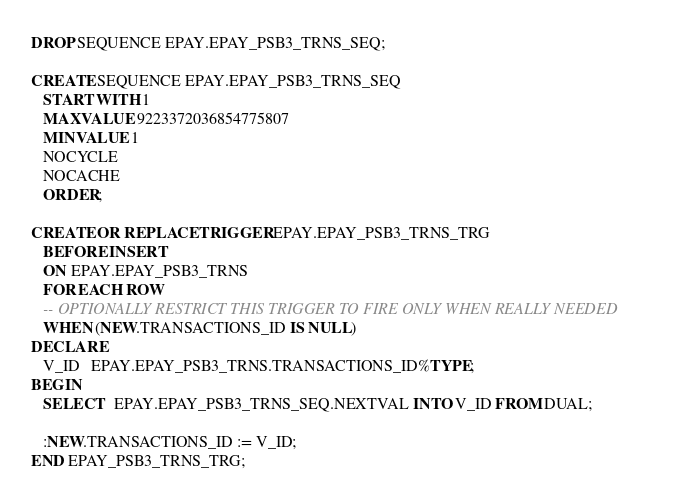<code> <loc_0><loc_0><loc_500><loc_500><_SQL_>DROP SEQUENCE EPAY.EPAY_PSB3_TRNS_SEQ;

CREATE SEQUENCE EPAY.EPAY_PSB3_TRNS_SEQ
   START WITH 1
   MAXVALUE 9223372036854775807
   MINVALUE 1
   NOCYCLE
   NOCACHE
   ORDER;

CREATE OR REPLACE TRIGGER EPAY.EPAY_PSB3_TRNS_TRG
   BEFORE INSERT
   ON EPAY.EPAY_PSB3_TRNS
   FOR EACH ROW
   -- OPTIONALLY RESTRICT THIS TRIGGER TO FIRE ONLY WHEN REALLY NEEDED
   WHEN (NEW.TRANSACTIONS_ID IS NULL)
DECLARE
   V_ID   EPAY.EPAY_PSB3_TRNS.TRANSACTIONS_ID%TYPE;
BEGIN
   SELECT   EPAY.EPAY_PSB3_TRNS_SEQ.NEXTVAL INTO V_ID FROM DUAL;

   :NEW.TRANSACTIONS_ID := V_ID;
END EPAY_PSB3_TRNS_TRG;</code> 